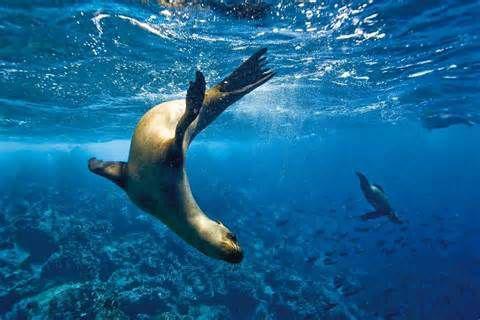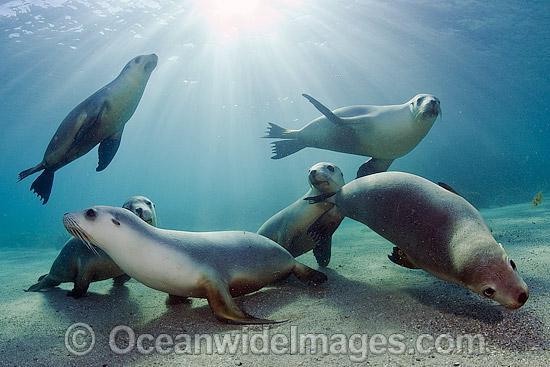The first image is the image on the left, the second image is the image on the right. Examine the images to the left and right. Is the description "One of the images shows the surface of the ocean with at least two otters popping their heads out of the water." accurate? Answer yes or no. No. The first image is the image on the left, the second image is the image on the right. For the images displayed, is the sentence "There are at least eight sea lions in total." factually correct? Answer yes or no. Yes. 